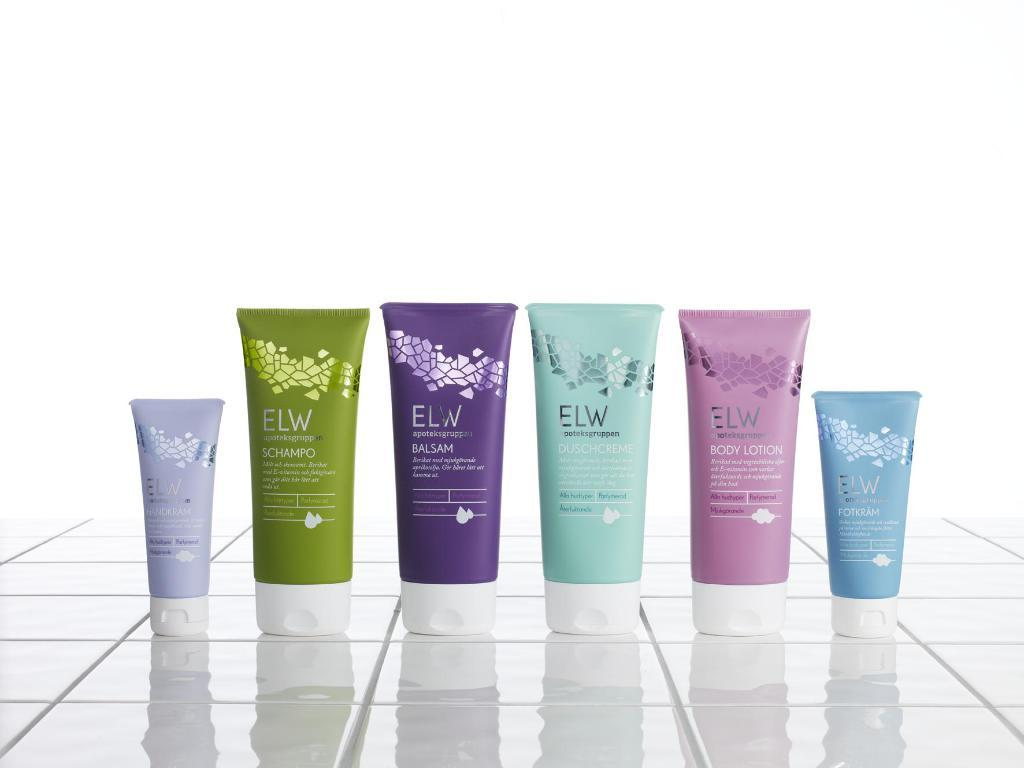What objects are present in the image? There are tubes of different colors in the image. What information can be found at the bottom of the image? There are titles at the bottom of the image. What color is the background of the image? The background of the image is white. Where is the chicken located in the image? There is no chicken present in the image. What type of frame surrounds the image? The image does not show a frame; it only displays the tubes and titles. 